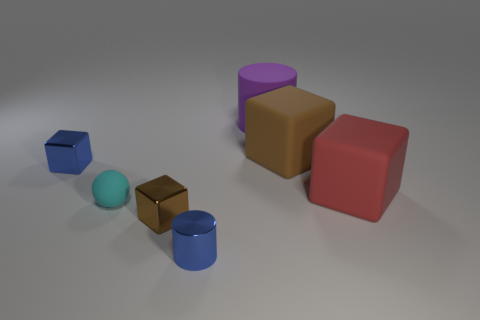Is there any other thing that has the same material as the large purple object?
Your answer should be very brief. Yes. Do the brown thing that is on the left side of the big brown rubber thing and the purple thing have the same material?
Ensure brevity in your answer.  No. The large block in front of the tiny metal cube that is to the left of the brown thing that is left of the large brown block is made of what material?
Provide a succinct answer. Rubber. What number of other objects are the same shape as the small brown shiny object?
Your answer should be very brief. 3. What color is the cube on the left side of the tiny brown shiny block?
Your answer should be compact. Blue. There is a rubber object to the right of the large brown rubber cube on the right side of the small cyan ball; what number of cyan objects are to the left of it?
Offer a very short reply. 1. What number of big matte cylinders are on the left side of the block that is in front of the big red block?
Your response must be concise. 0. There is a brown metallic object; what number of shiny objects are behind it?
Your response must be concise. 1. What number of other things are the same size as the ball?
Provide a short and direct response. 3. There is another matte object that is the same shape as the red matte object; what size is it?
Give a very brief answer. Large. 